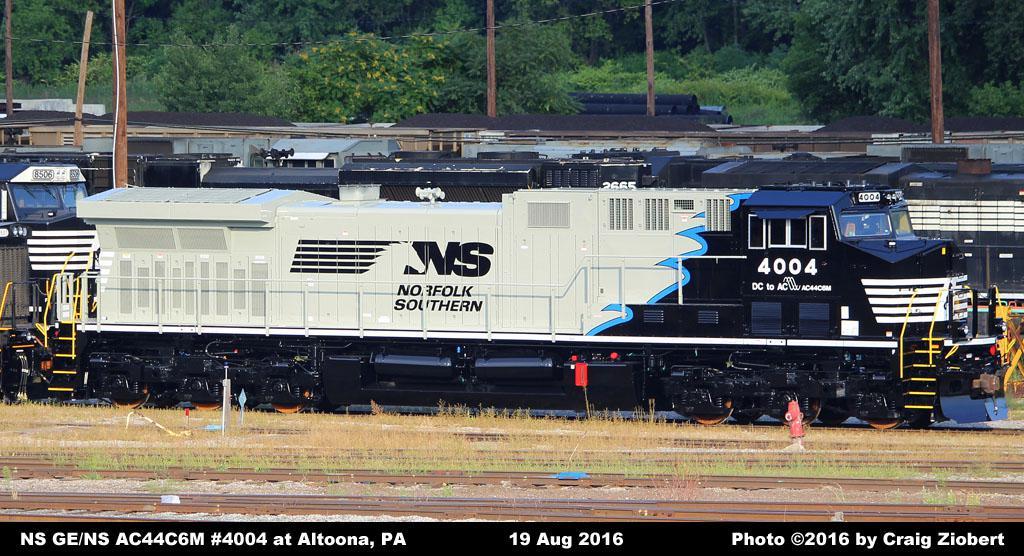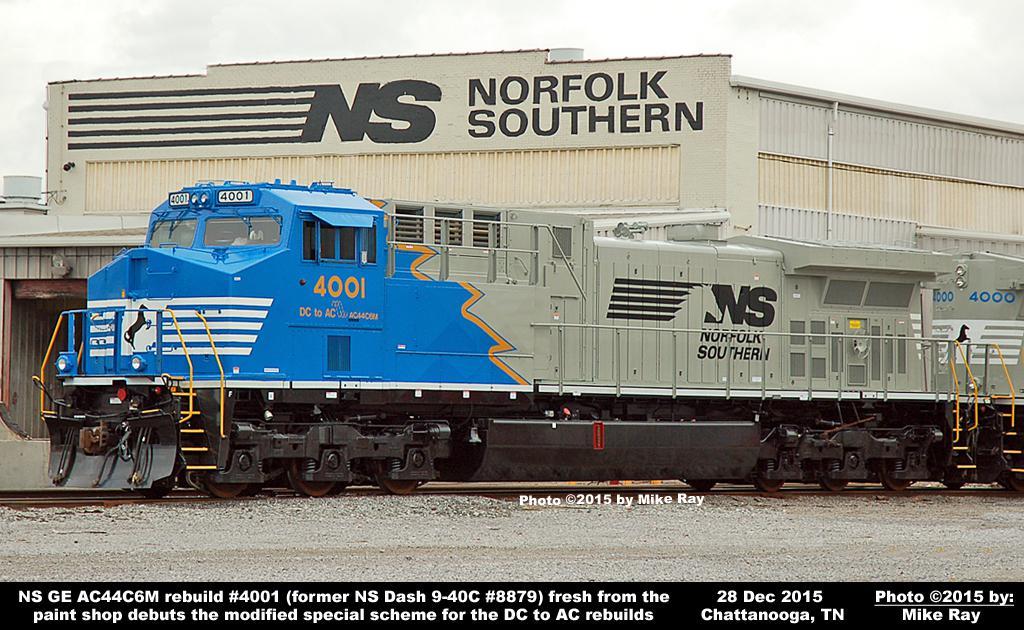The first image is the image on the left, the second image is the image on the right. Assess this claim about the two images: "The left image contains a train that is headed towards the right.". Correct or not? Answer yes or no. Yes. The first image is the image on the left, the second image is the image on the right. Assess this claim about the two images: "A train has a bright yellow front and faces leftward.". Correct or not? Answer yes or no. No. 